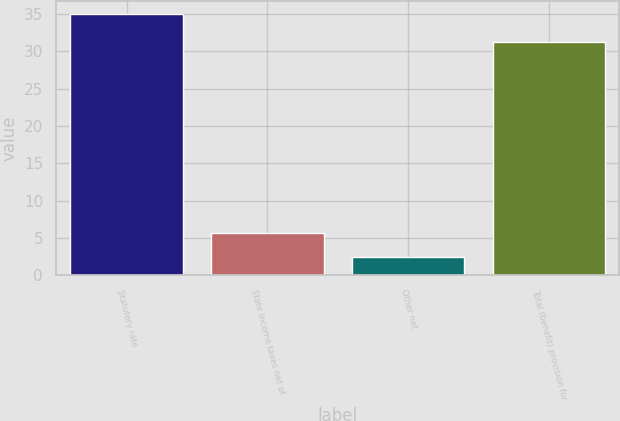Convert chart to OTSL. <chart><loc_0><loc_0><loc_500><loc_500><bar_chart><fcel>Statutory rate<fcel>State income taxes net of<fcel>Other net<fcel>Total (benefit) provision for<nl><fcel>35<fcel>5.75<fcel>2.5<fcel>31.2<nl></chart> 